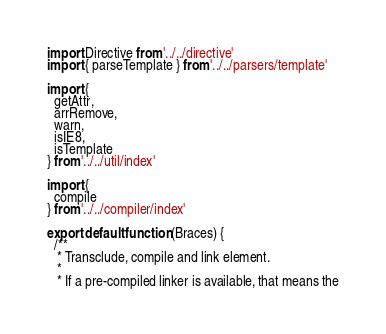Convert code to text. <code><loc_0><loc_0><loc_500><loc_500><_JavaScript_>import Directive from '../../directive'
import { parseTemplate } from '../../parsers/template'

import {
  getAttr,
  arrRemove,
  warn,
  isIE8,
  isTemplate
} from '../../util/index'

import {
  compile
} from '../../compiler/index'

export default function (Braces) {
  /**
   * Transclude, compile and link element.
   *
   * If a pre-compiled linker is available, that means the</code> 